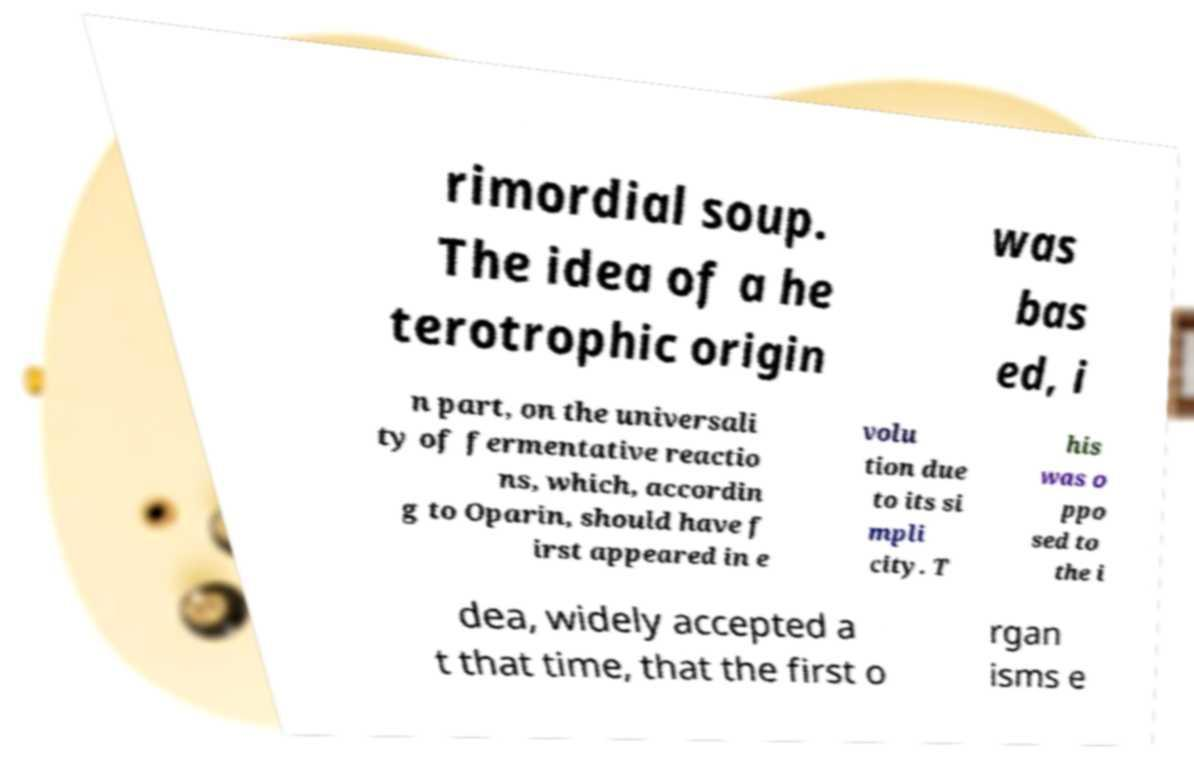What messages or text are displayed in this image? I need them in a readable, typed format. rimordial soup. The idea of a he terotrophic origin was bas ed, i n part, on the universali ty of fermentative reactio ns, which, accordin g to Oparin, should have f irst appeared in e volu tion due to its si mpli city. T his was o ppo sed to the i dea, widely accepted a t that time, that the first o rgan isms e 